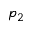<formula> <loc_0><loc_0><loc_500><loc_500>p _ { 2 }</formula> 